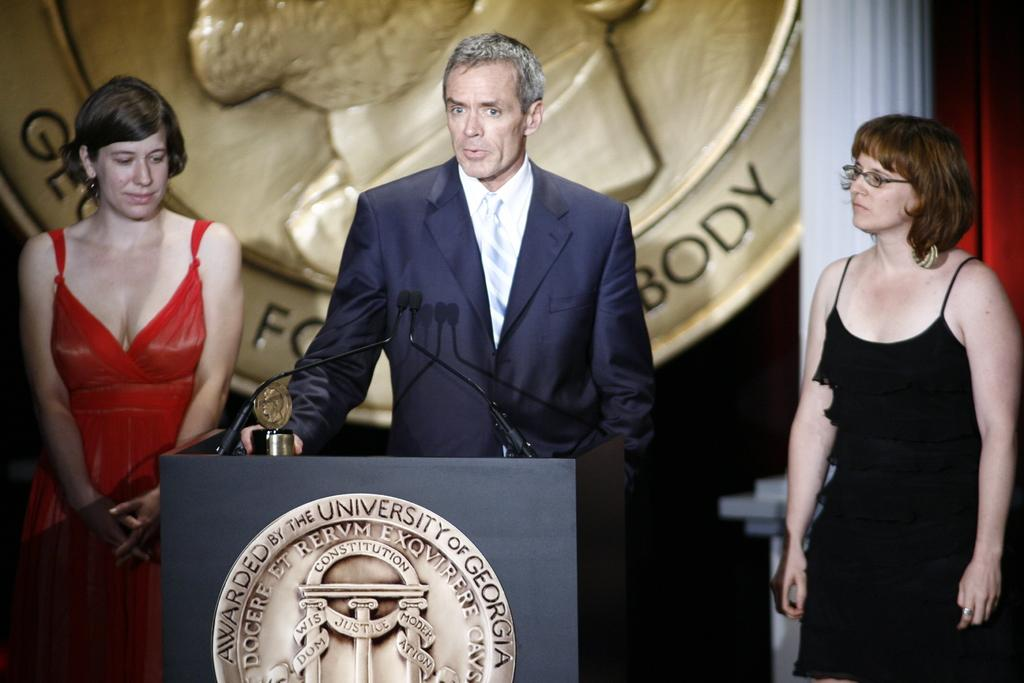How many people are in the image? There are three people in the image: one man and two women. What is the man holding in the image? The man is holding a shield in the image. What objects are in front of the man? There are microphones and a podium in front of the man. What type of transport is the carpenter using in the image? There is no carpenter or transport present in the image. What time of day is it in the image? The time of day is not mentioned in the image, so it cannot be determined. 